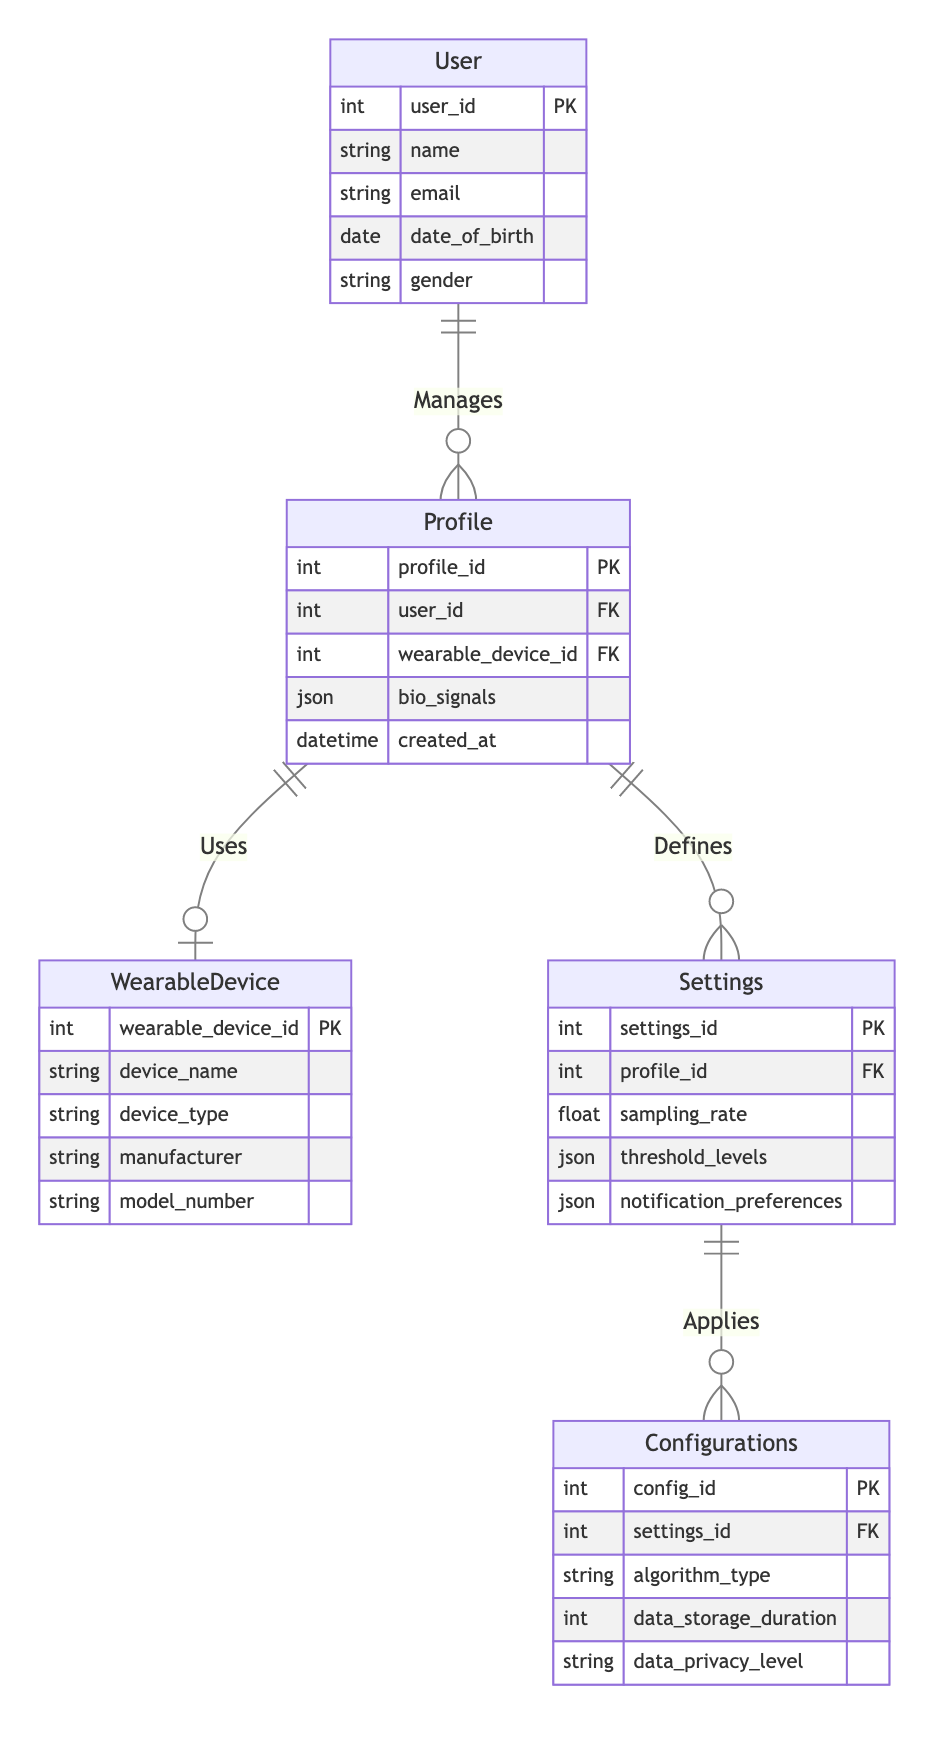What is the primary relationship between User and Profile? The diagram shows that the User manages the Profile, indicated by the "Manages" relationship between the two entities. This means that each User can create or oversee one or more Profiles.
Answer: Manages How many attributes does the Settings entity have? Counting the attributes listed under the Settings entity in the diagram, we have sampling rate, threshold levels, and notification preferences, which totals three attributes.
Answer: 5 What is the identifier for the WearableDevice entity? The identifier for the WearableDevice is wearable_device_id, which is marked as a primary key under this entity in the diagram.
Answer: wearable_device_id Which entity directly depends on the Settings entity? The Configurations entity is directly dependent on the Settings entity, shown by the "Applies" relationship connecting them. This indicates that Configurations depend on specific Settings established by the Profile.
Answer: Configurations How many entities are present in the diagram? There are five entities listed in the diagram, which include User, Profile, WearableDevice, Settings, and Configurations. By counting these, we find the total.
Answer: 5 What type of relationship is between Profile and WearableDevice? The relationship between Profile and WearableDevice is defined as "Uses," indicating that a Profile is associated with a specific WearableDevice for monitoring purposes.
Answer: Uses What does the User entity control in this system? The User entity controls the Profile entity, as indicated by the "Manages" relationship. The control signifies that users have the ability to manage one or more profiles associated with themselves.
Answer: Profile Which entity holds the attributes related to data privacy? The Configurations entity holds attributes related to data privacy, specifically the data_privacy_level attribute, which is included under this entity in the diagram.
Answer: Configurations What is the number of foreign key relationships involving the Profile entity? The Profile entity has two foreign key relationships: one with the User entity (user_id) and another with the WearableDevice entity (wearable_device_id), totaling two foreign key relationships.
Answer: 2 